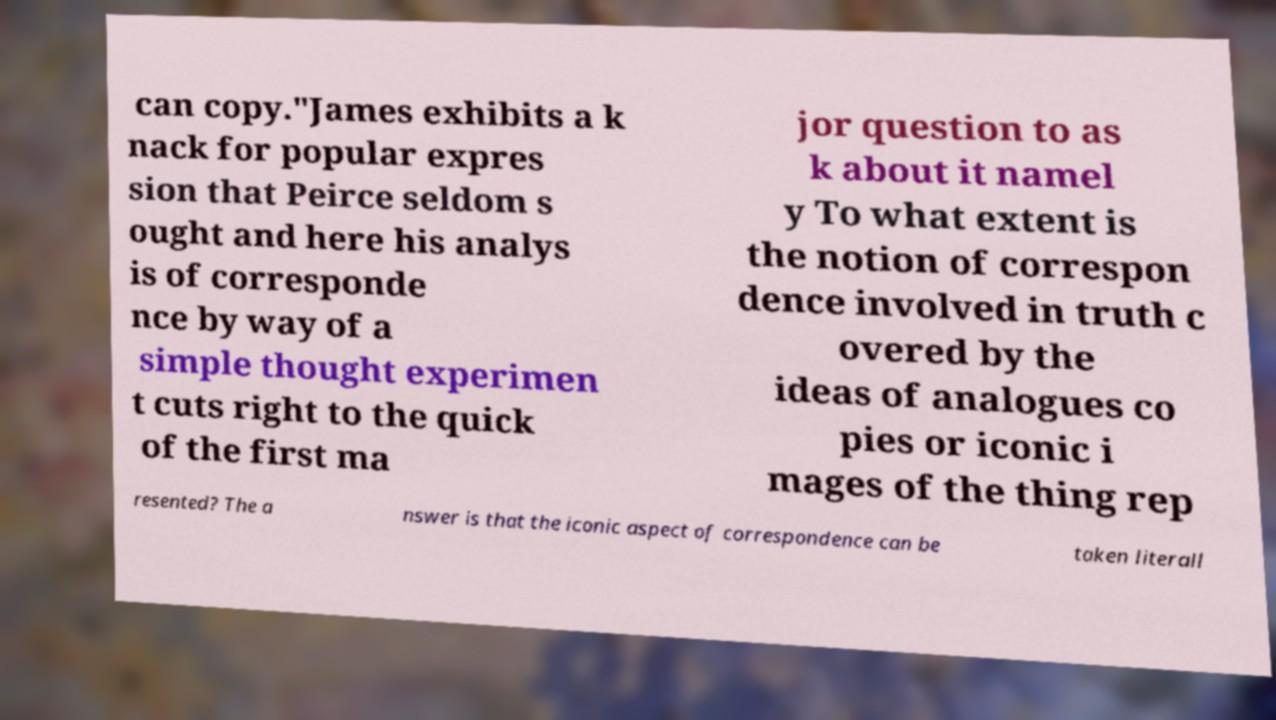Can you accurately transcribe the text from the provided image for me? can copy."James exhibits a k nack for popular expres sion that Peirce seldom s ought and here his analys is of corresponde nce by way of a simple thought experimen t cuts right to the quick of the first ma jor question to as k about it namel y To what extent is the notion of correspon dence involved in truth c overed by the ideas of analogues co pies or iconic i mages of the thing rep resented? The a nswer is that the iconic aspect of correspondence can be taken literall 